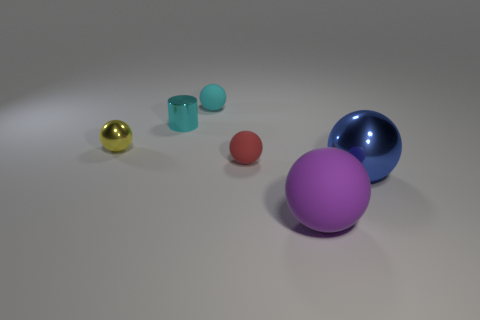Subtract 1 balls. How many balls are left? 4 Subtract all yellow balls. How many balls are left? 4 Subtract all yellow metal spheres. How many spheres are left? 4 Add 2 balls. How many objects exist? 8 Subtract all brown balls. Subtract all yellow cylinders. How many balls are left? 5 Subtract all balls. How many objects are left? 1 Add 6 red matte balls. How many red matte balls exist? 7 Subtract 1 yellow spheres. How many objects are left? 5 Subtract all tiny matte objects. Subtract all gray blocks. How many objects are left? 4 Add 3 big matte things. How many big matte things are left? 4 